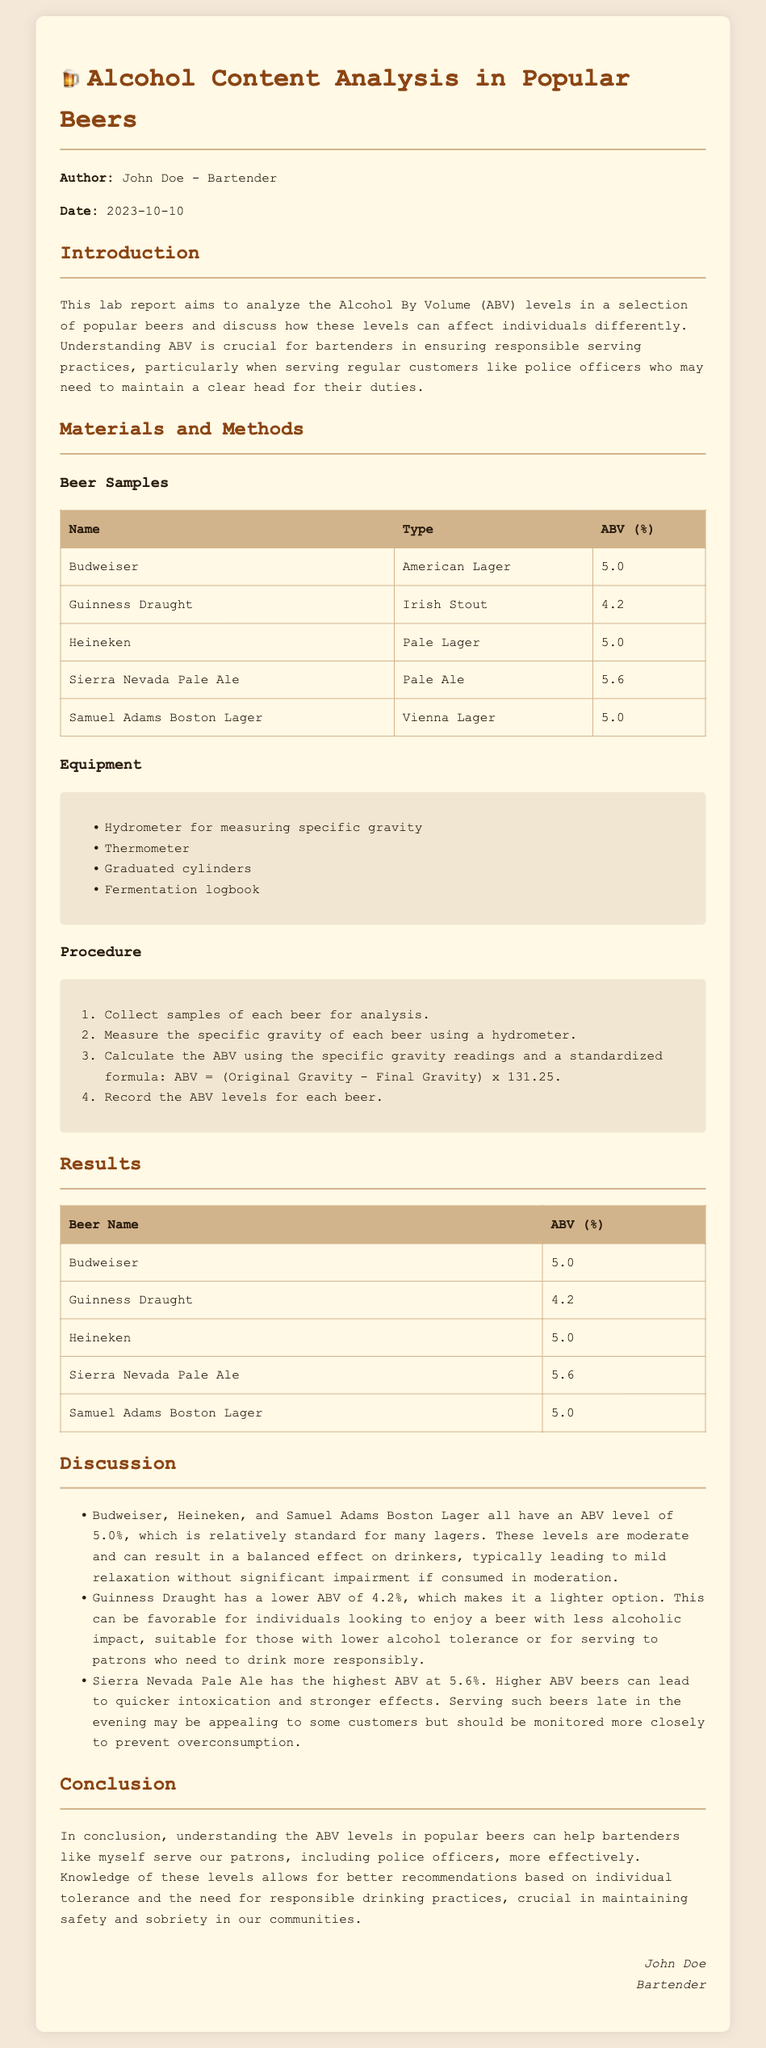what was the date of the report? The report was dated October 10, 2023.
Answer: October 10, 2023 who is the author of the report? The author of the report is John Doe.
Answer: John Doe what is the highest ABV level recorded in the analysis? The highest ABV level recorded was 5.6% for Sierra Nevada Pale Ale.
Answer: 5.6% which beer has an ABV of 4.2%? Guinness Draught is the beer that has an ABV of 4.2%.
Answer: Guinness Draught how many different types of beers were analyzed? Five different types of beers were analyzed as mentioned in the report.
Answer: five what equipment is used to measure specific gravity? The equipment used to measure specific gravity is a hydrometer.
Answer: hydrometer what is the primary purpose of the lab report? The primary purpose of the lab report is to analyze ABV levels in popular beers.
Answer: analyze ABV levels how can knowledge of ABV levels benefit bartenders? Knowledge of ABV levels can help bartenders recommend drinks based on individual tolerance and promote responsible drinking.
Answer: promote responsible drinking which beer types are indicated in the analysis? The beer types indicated in the analysis are American Lager, Irish Stout, Pale Lager, Pale Ale, and Vienna Lager.
Answer: American Lager, Irish Stout, Pale Lager, Pale Ale, Vienna Lager 